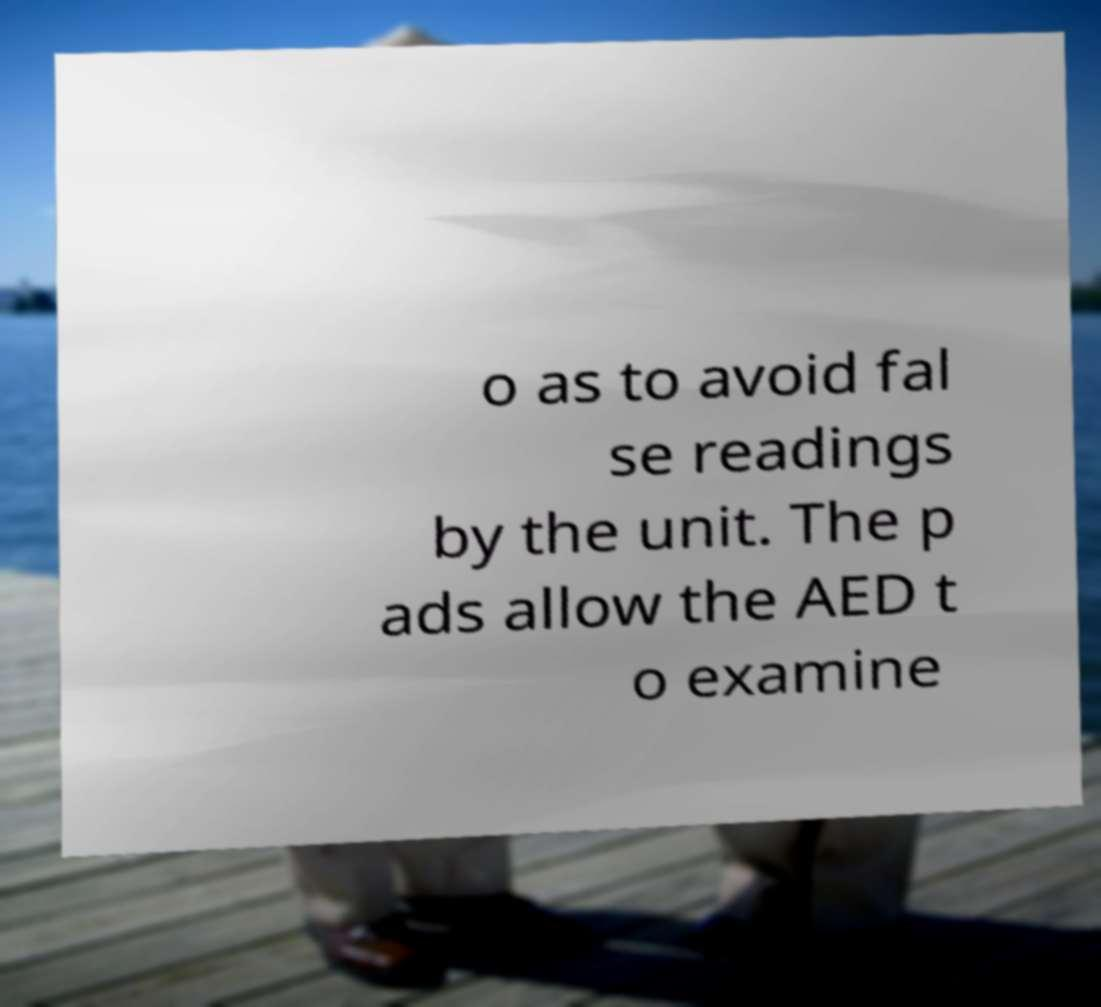Can you read and provide the text displayed in the image?This photo seems to have some interesting text. Can you extract and type it out for me? o as to avoid fal se readings by the unit. The p ads allow the AED t o examine 